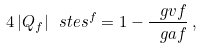<formula> <loc_0><loc_0><loc_500><loc_500>4 \, | Q _ { f } | \ s t e s ^ { f } = 1 - \frac { \ g v f } { \ g a f } \, ,</formula> 